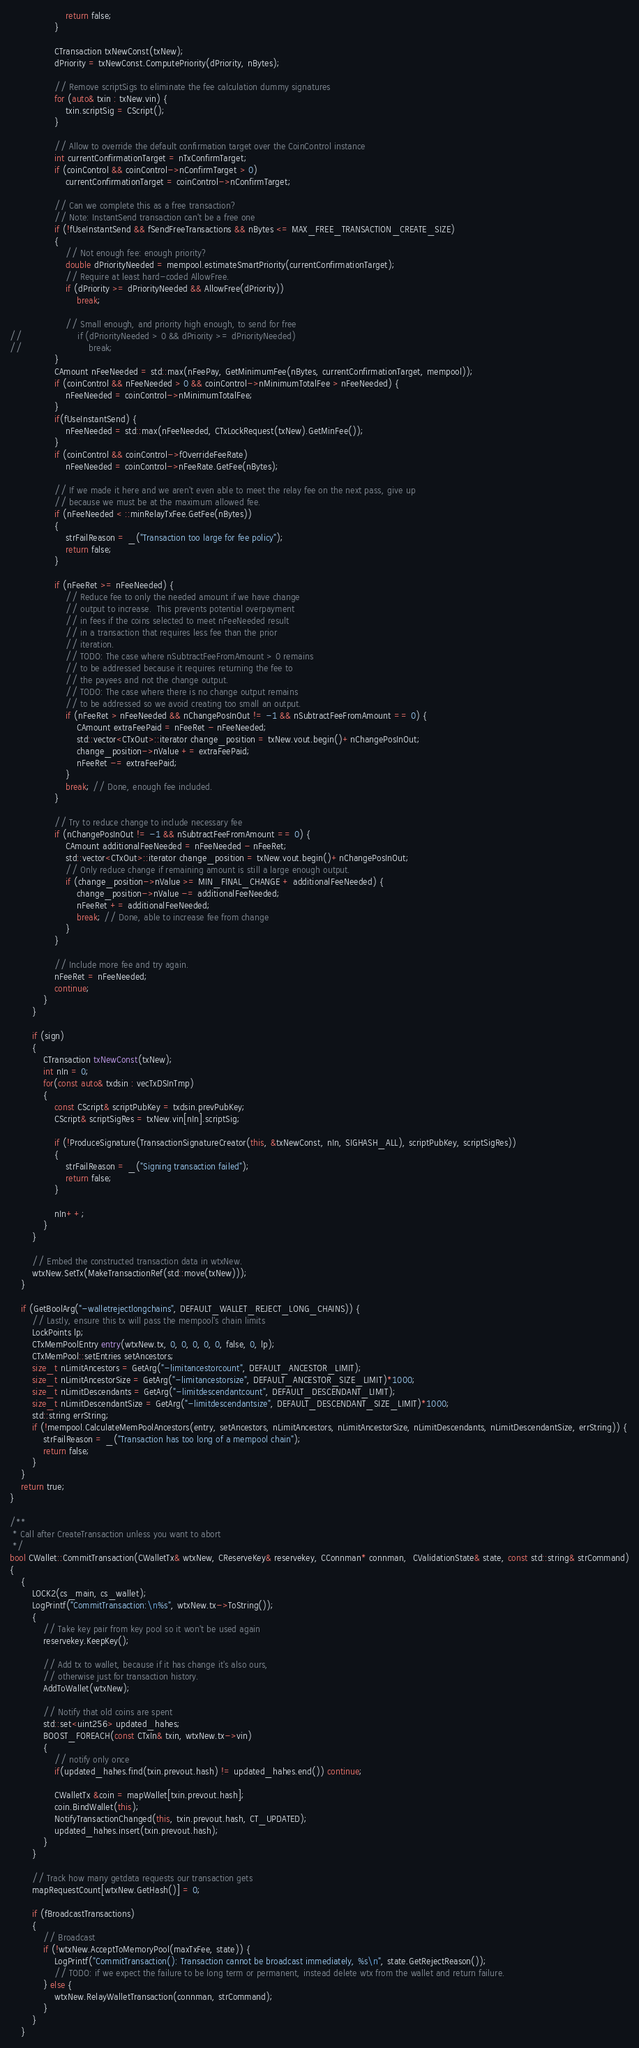Convert code to text. <code><loc_0><loc_0><loc_500><loc_500><_C++_>                    return false;
                }

                CTransaction txNewConst(txNew);
                dPriority = txNewConst.ComputePriority(dPriority, nBytes);

                // Remove scriptSigs to eliminate the fee calculation dummy signatures
                for (auto& txin : txNew.vin) {
                    txin.scriptSig = CScript();
                }

                // Allow to override the default confirmation target over the CoinControl instance
                int currentConfirmationTarget = nTxConfirmTarget;
                if (coinControl && coinControl->nConfirmTarget > 0)
                    currentConfirmationTarget = coinControl->nConfirmTarget;

                // Can we complete this as a free transaction?
                // Note: InstantSend transaction can't be a free one
                if (!fUseInstantSend && fSendFreeTransactions && nBytes <= MAX_FREE_TRANSACTION_CREATE_SIZE)
                {
                    // Not enough fee: enough priority?
                    double dPriorityNeeded = mempool.estimateSmartPriority(currentConfirmationTarget);
                    // Require at least hard-coded AllowFree.
                    if (dPriority >= dPriorityNeeded && AllowFree(dPriority))
                        break;

                    // Small enough, and priority high enough, to send for free
//                    if (dPriorityNeeded > 0 && dPriority >= dPriorityNeeded)
//                        break;
                }
                CAmount nFeeNeeded = std::max(nFeePay, GetMinimumFee(nBytes, currentConfirmationTarget, mempool));
                if (coinControl && nFeeNeeded > 0 && coinControl->nMinimumTotalFee > nFeeNeeded) {
                    nFeeNeeded = coinControl->nMinimumTotalFee;
                }
                if(fUseInstantSend) {
                    nFeeNeeded = std::max(nFeeNeeded, CTxLockRequest(txNew).GetMinFee());
                }
                if (coinControl && coinControl->fOverrideFeeRate)
                    nFeeNeeded = coinControl->nFeeRate.GetFee(nBytes);

                // If we made it here and we aren't even able to meet the relay fee on the next pass, give up
                // because we must be at the maximum allowed fee.
                if (nFeeNeeded < ::minRelayTxFee.GetFee(nBytes))
                {
                    strFailReason = _("Transaction too large for fee policy");
                    return false;
                }

                if (nFeeRet >= nFeeNeeded) {
                    // Reduce fee to only the needed amount if we have change
                    // output to increase.  This prevents potential overpayment
                    // in fees if the coins selected to meet nFeeNeeded result
                    // in a transaction that requires less fee than the prior
                    // iteration.
                    // TODO: The case where nSubtractFeeFromAmount > 0 remains
                    // to be addressed because it requires returning the fee to
                    // the payees and not the change output.
                    // TODO: The case where there is no change output remains
                    // to be addressed so we avoid creating too small an output.
                    if (nFeeRet > nFeeNeeded && nChangePosInOut != -1 && nSubtractFeeFromAmount == 0) {
                        CAmount extraFeePaid = nFeeRet - nFeeNeeded;
                        std::vector<CTxOut>::iterator change_position = txNew.vout.begin()+nChangePosInOut;
                        change_position->nValue += extraFeePaid;
                        nFeeRet -= extraFeePaid;
                    }
                    break; // Done, enough fee included.
                }

                // Try to reduce change to include necessary fee
                if (nChangePosInOut != -1 && nSubtractFeeFromAmount == 0) {
                    CAmount additionalFeeNeeded = nFeeNeeded - nFeeRet;
                    std::vector<CTxOut>::iterator change_position = txNew.vout.begin()+nChangePosInOut;
                    // Only reduce change if remaining amount is still a large enough output.
                    if (change_position->nValue >= MIN_FINAL_CHANGE + additionalFeeNeeded) {
                        change_position->nValue -= additionalFeeNeeded;
                        nFeeRet += additionalFeeNeeded;
                        break; // Done, able to increase fee from change
                    }
                }

                // Include more fee and try again.
                nFeeRet = nFeeNeeded;
                continue;
            }
        }

        if (sign)
        {
            CTransaction txNewConst(txNew);
            int nIn = 0;
            for(const auto& txdsin : vecTxDSInTmp)
            {
                const CScript& scriptPubKey = txdsin.prevPubKey;
                CScript& scriptSigRes = txNew.vin[nIn].scriptSig;

                if (!ProduceSignature(TransactionSignatureCreator(this, &txNewConst, nIn, SIGHASH_ALL), scriptPubKey, scriptSigRes))
                {
                    strFailReason = _("Signing transaction failed");
                    return false;
                }

                nIn++;
            }
        }

        // Embed the constructed transaction data in wtxNew.
        wtxNew.SetTx(MakeTransactionRef(std::move(txNew)));
    }

    if (GetBoolArg("-walletrejectlongchains", DEFAULT_WALLET_REJECT_LONG_CHAINS)) {
        // Lastly, ensure this tx will pass the mempool's chain limits
        LockPoints lp;
        CTxMemPoolEntry entry(wtxNew.tx, 0, 0, 0, 0, 0, false, 0, lp);
        CTxMemPool::setEntries setAncestors;
        size_t nLimitAncestors = GetArg("-limitancestorcount", DEFAULT_ANCESTOR_LIMIT);
        size_t nLimitAncestorSize = GetArg("-limitancestorsize", DEFAULT_ANCESTOR_SIZE_LIMIT)*1000;
        size_t nLimitDescendants = GetArg("-limitdescendantcount", DEFAULT_DESCENDANT_LIMIT);
        size_t nLimitDescendantSize = GetArg("-limitdescendantsize", DEFAULT_DESCENDANT_SIZE_LIMIT)*1000;
        std::string errString;
        if (!mempool.CalculateMemPoolAncestors(entry, setAncestors, nLimitAncestors, nLimitAncestorSize, nLimitDescendants, nLimitDescendantSize, errString)) {
            strFailReason = _("Transaction has too long of a mempool chain");
            return false;
        }
    }
    return true;
}

/**
 * Call after CreateTransaction unless you want to abort
 */
bool CWallet::CommitTransaction(CWalletTx& wtxNew, CReserveKey& reservekey, CConnman* connman,  CValidationState& state, const std::string& strCommand)
{
    {
        LOCK2(cs_main, cs_wallet);
        LogPrintf("CommitTransaction:\n%s", wtxNew.tx->ToString());
        {
            // Take key pair from key pool so it won't be used again
            reservekey.KeepKey();

            // Add tx to wallet, because if it has change it's also ours,
            // otherwise just for transaction history.
            AddToWallet(wtxNew);

            // Notify that old coins are spent
            std::set<uint256> updated_hahes;
            BOOST_FOREACH(const CTxIn& txin, wtxNew.tx->vin)
            {
                // notify only once
                if(updated_hahes.find(txin.prevout.hash) != updated_hahes.end()) continue;

                CWalletTx &coin = mapWallet[txin.prevout.hash];
                coin.BindWallet(this);
                NotifyTransactionChanged(this, txin.prevout.hash, CT_UPDATED);
                updated_hahes.insert(txin.prevout.hash);
            }
        }

        // Track how many getdata requests our transaction gets
        mapRequestCount[wtxNew.GetHash()] = 0;

        if (fBroadcastTransactions)
        {
            // Broadcast
            if (!wtxNew.AcceptToMemoryPool(maxTxFee, state)) {
                LogPrintf("CommitTransaction(): Transaction cannot be broadcast immediately, %s\n", state.GetRejectReason());
                // TODO: if we expect the failure to be long term or permanent, instead delete wtx from the wallet and return failure.
            } else {
                wtxNew.RelayWalletTransaction(connman, strCommand);
            }
        }
    }</code> 